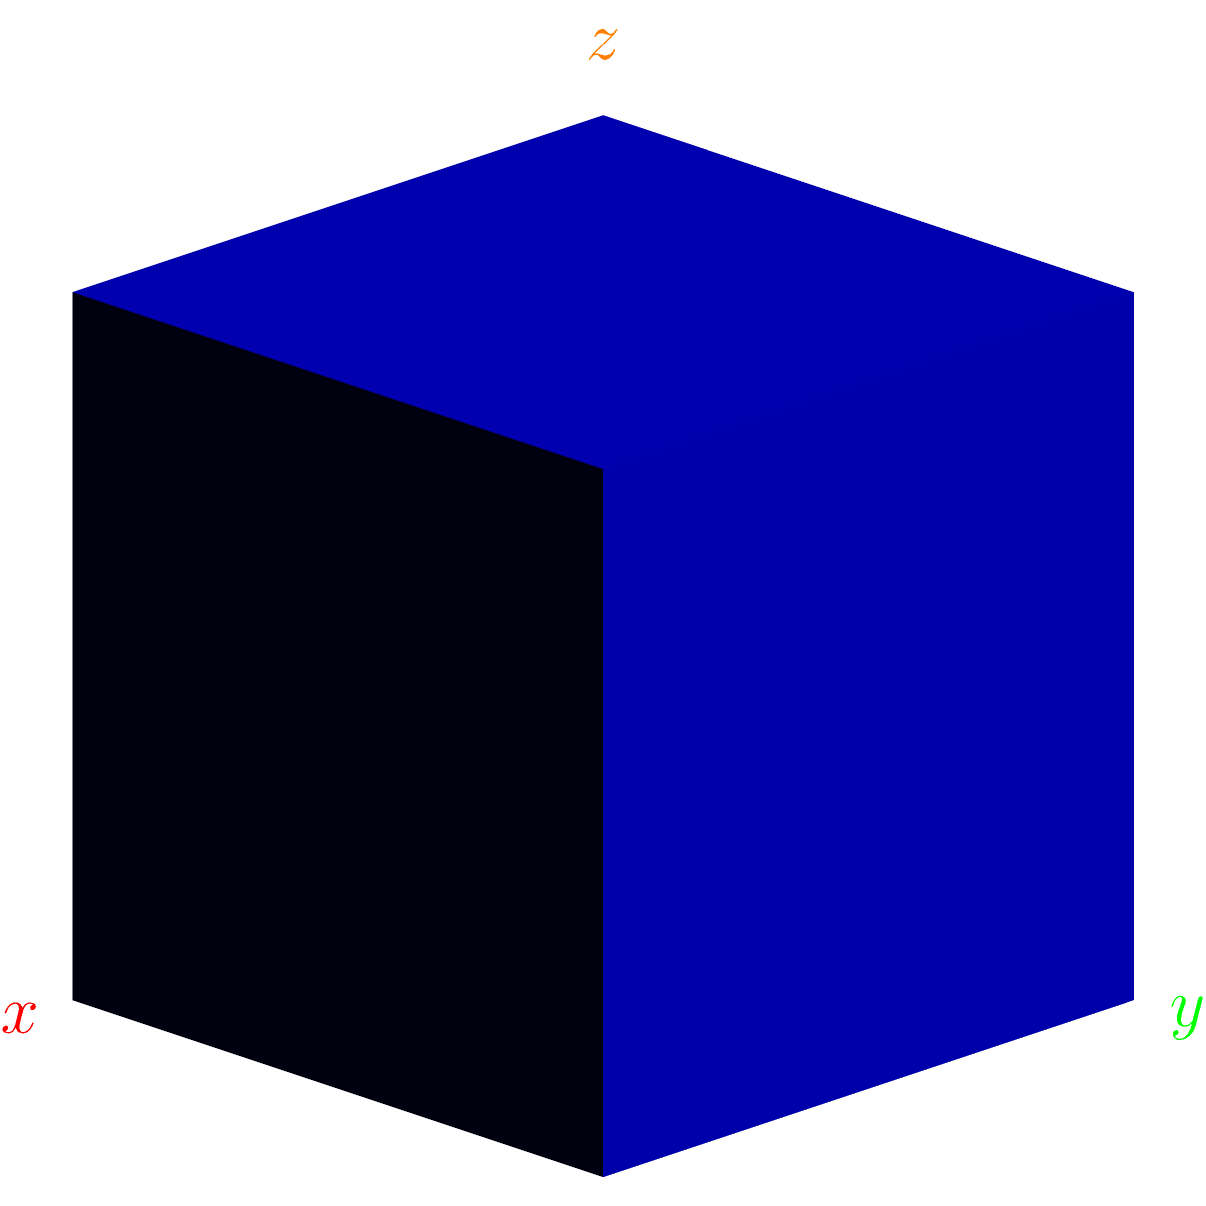In the context of mapping 3D anatomical structures onto 2D projection images, consider a point $P(0.7, 0.5, 0.6)$ in a 3D coordinate system. If this point is orthographically projected onto the xy-plane, what are the coordinates of the projected point $P'$? To find the coordinates of the projected point $P'$, we need to follow these steps:

1. Understand orthographic projection:
   Orthographic projection onto the xy-plane means that we're essentially "dropping" the z-coordinate and keeping the x and y coordinates the same.

2. Identify the original coordinates:
   The original point $P$ has coordinates $(0.7, 0.5, 0.6)$.

3. Project onto the xy-plane:
   - The x-coordinate remains 0.7
   - The y-coordinate remains 0.5
   - The z-coordinate becomes 0 (as we're projecting onto the xy-plane)

4. Write the new coordinates:
   The projected point $P'$ will have coordinates $(0.7, 0.5, 0)$.

In the context of medical imaging, this process is similar to how 3D anatomical structures are mapped onto 2D images in projection-based imaging modalities, albeit usually with more complex projection methods.
Answer: $(0.7, 0.5, 0)$ 